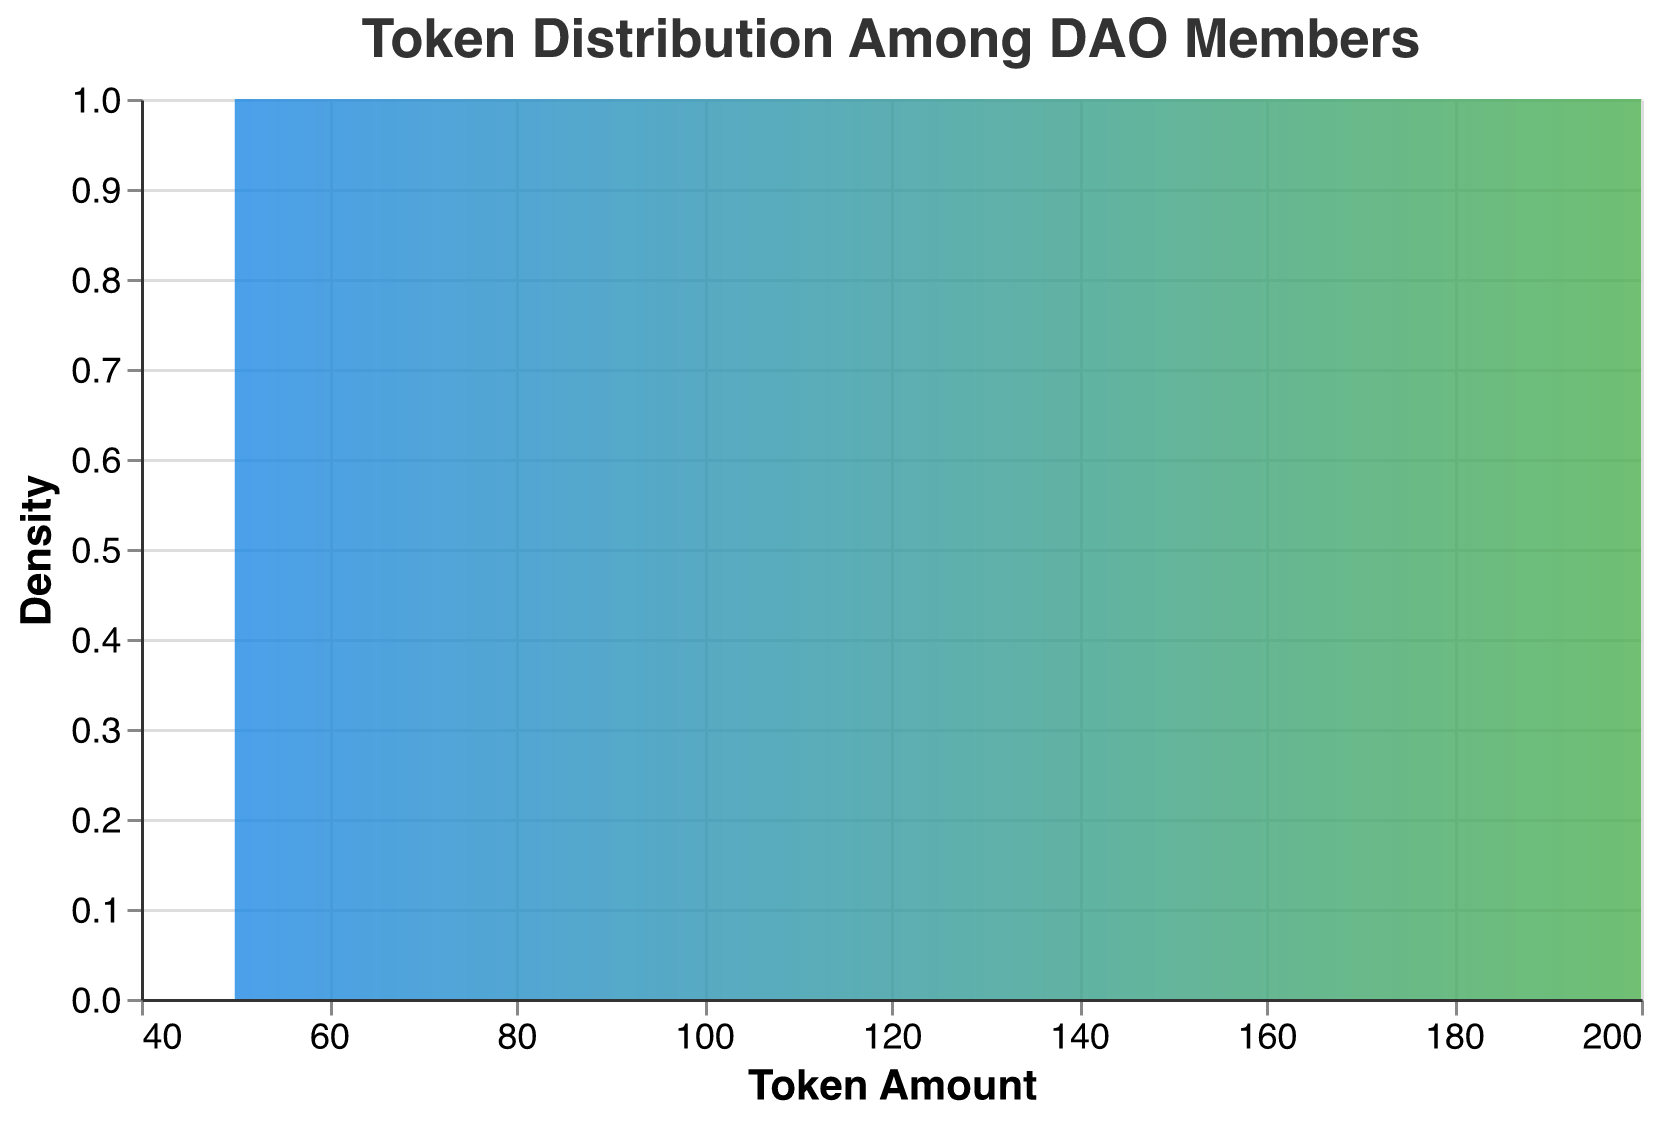What is the title of the figure? The title of the figure is usually found at the top and describes what the figure is about. In this case, it reads "Token Distribution Among DAO Members".
Answer: Token Distribution Among DAO Members What is the color gradient used for the density plot? The color gradient is a visual aspect of the figure, shifting from one color to another to indicate density. It starts with blue at one end and transitions to green at the other end.
Answer: Blue to Green What are the x-axis and y-axis titles? The titles for both axes are labels that describe what each axis represents. The x-axis title is "Token Amount", and the y-axis title is "Density".
Answer: Token Amount (x-axis), Density (y-axis) Where is the peak density observed along the token amount axis? The peak density is identified by the highest point on the y-axis in the plot. Around the x-axis value of 100 tokens, the density seems to be highest.
Answer: Around 100 tokens Is the distribution of token amounts among DAO members skewed? If yes, in which direction? Skewness can be determined by the shape of the density plot. A distribution is positively skewed if it extends more towards higher token amounts. The plot shows more members with lower token amounts, indicating a positive skew.
Answer: Yes, positively skewed How many members have between 50 and 100 tokens? To answer this, count the peaks that fall within the x-axis range of 50 to 100 tokens. By observing the plot, we see that there are peaks for 50, 55, 60, 65, 75, 80, 85, 90, and 95 tokens, summing up to 9 members.
Answer: 9 members What is the average amount of tokens held by DAO members shown in the plot? The average requires summing the token amounts of all members and dividing by the number of members. Sum is 150+120+90+50+80+200+170+110+130+95+60+75+155+140+180+55+85+135+100+65 = 2245; Divide by 20 members: 2245/20 = 112.25 tokens.
Answer: 112.25 tokens Which member holds the highest number of tokens and how many? To find this, we identify the highest point on the x-axis corresponding to a member. In this case, Frank holds the highest token amount of 200 tokens.
Answer: Frank, 200 tokens Which members hold exactly 60 tokens and 110 tokens? To answer this, identify the members corresponding to these x-axis points. Kathy holds 60 tokens, and Heidi holds 110 tokens.
Answer: Kathy (60), Heidi (110) Between which token amounts does the highest density decline occur? The highest density initially peaks around 100 tokens and then declines towards the higher end around 200 tokens. By observing the slope, the decline starts around 150 tokens.
Answer: Between 100 and 150 tokens 